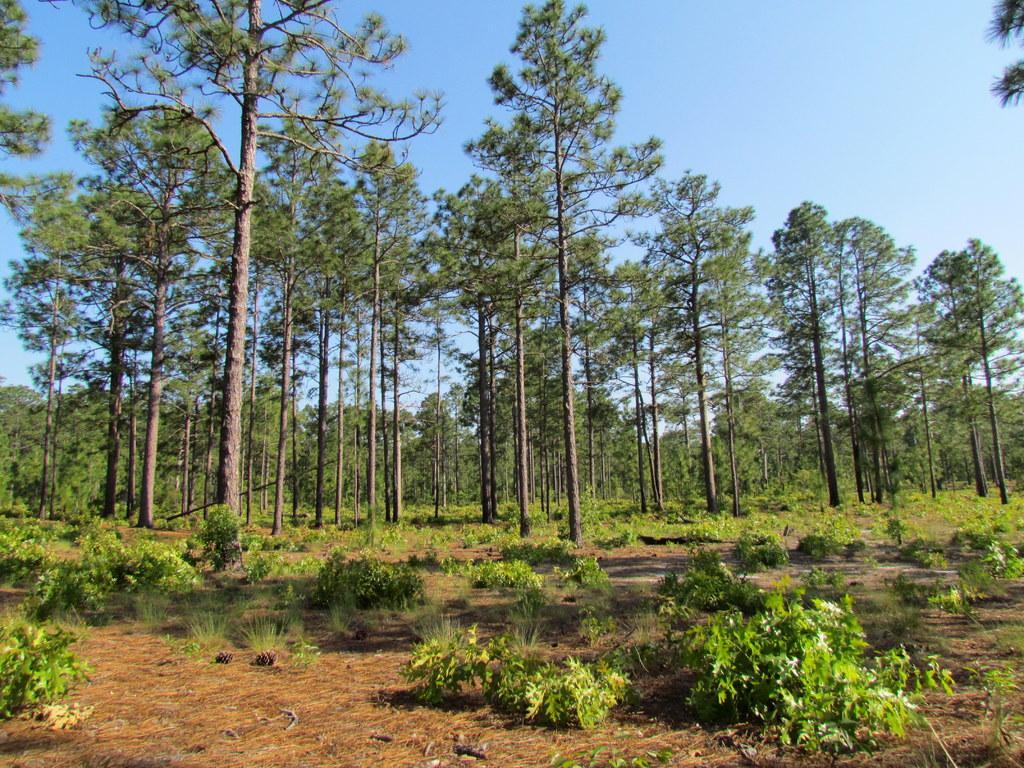Could you give a brief overview of what you see in this image? In the image we can see there are lot of trees and there are small plants on the ground. 